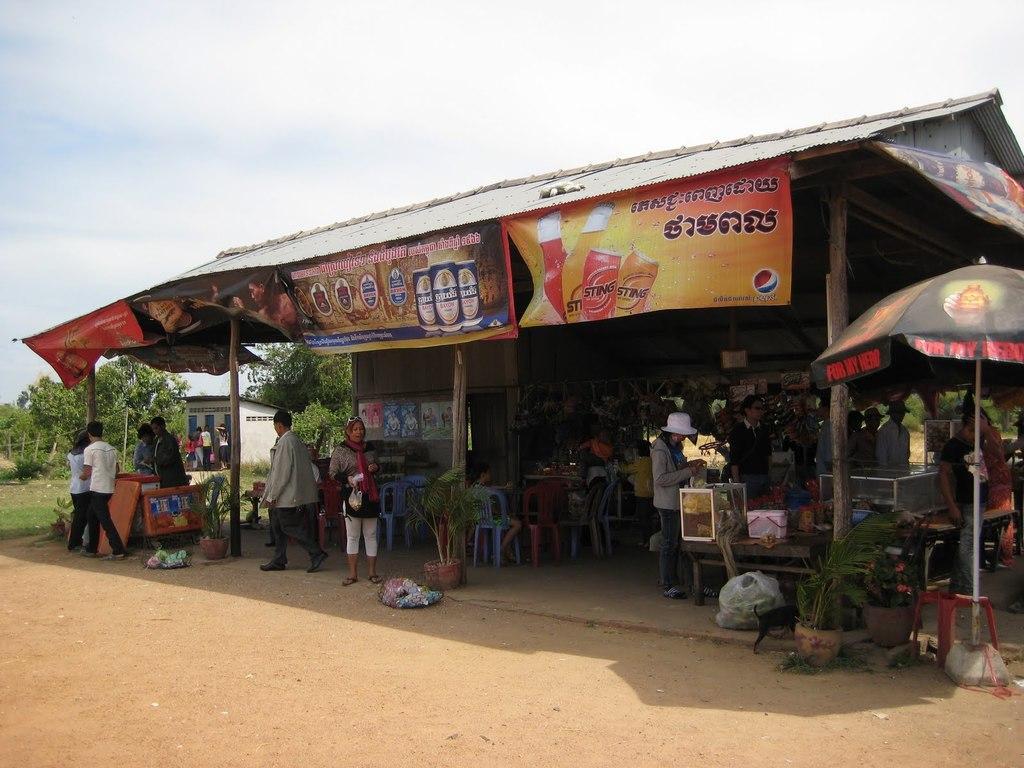Could you give a brief overview of what you see in this image? At the bottom we can see the ground and there is a shop where we can see few persons are standing and walking on the ground and we can see chairs, banners, an umbrella and other objects. In the background we can see trees, few persons standing at the washroom on the left side and clouds in the sky. 